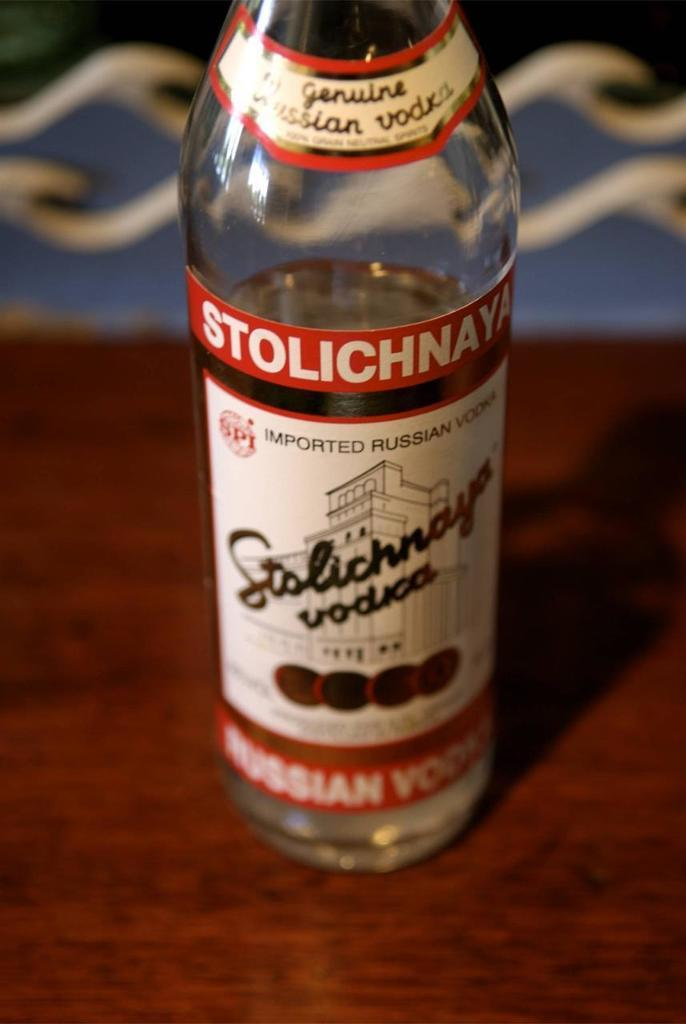<image>
Offer a succinct explanation of the picture presented. A bottle of Stolichnaya Genuine Russian Vodka sits on a wood surface. 